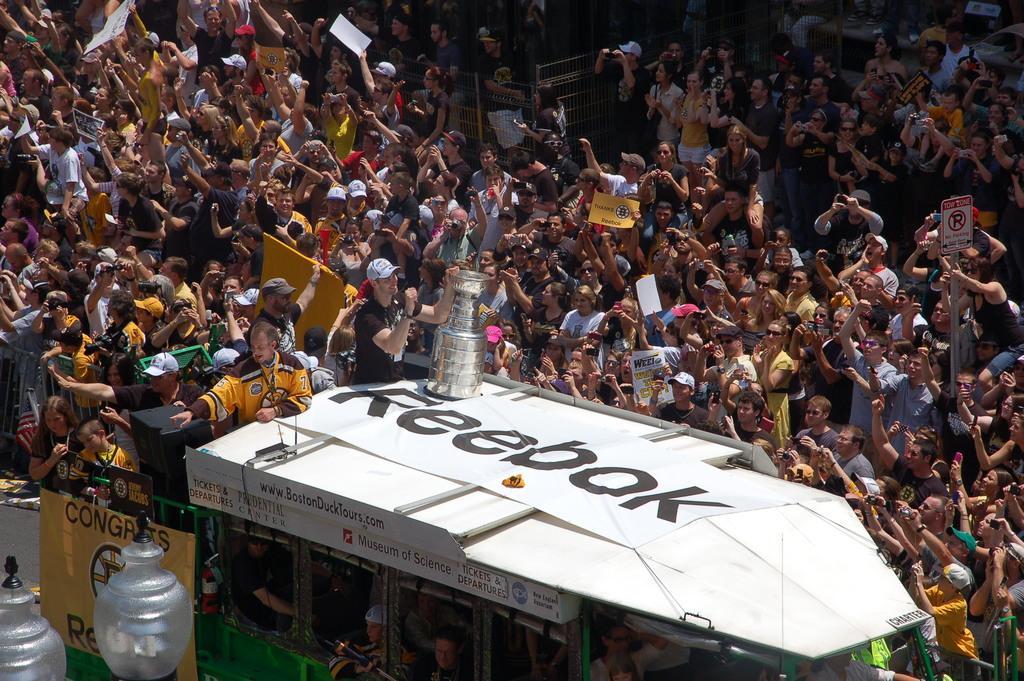How would you summarize this image in a sentence or two? In this image I can see a crowd of people and I can see a people on the van and in the van and van visible at the bottom and I can see lights visible in the bottom left. 